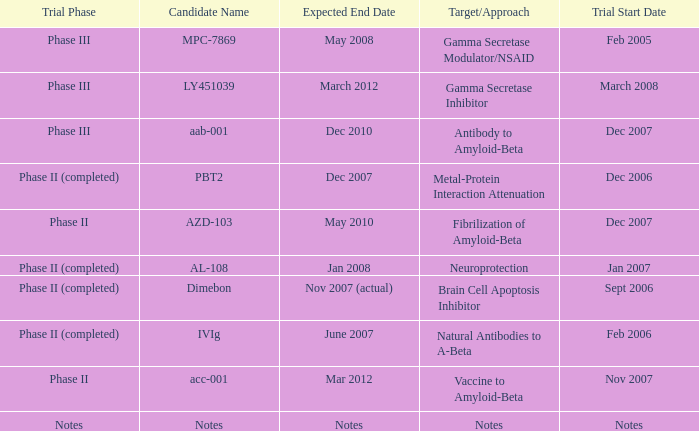What is Expected End Date, when Trial Start Date is Nov 2007? Mar 2012. 